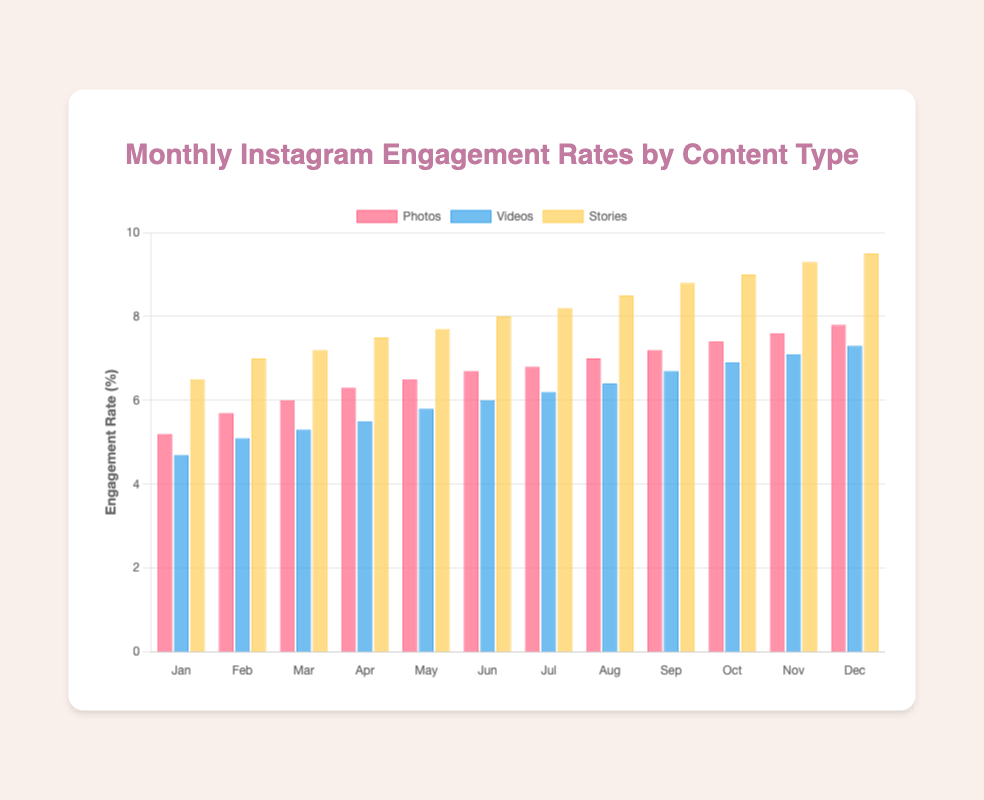What month had the highest engagement rate for stories? Stories had the highest engagement rate in December. By looking at the height of the yellow bars representing stories, December's bar is the tallest.
Answer: December Which content type had the lowest engagement rate in January? By comparing the heights of the bars for January, the blue bar (Videos) is the shortest, indicating it's the content type with the lowest engagement rate for that month.
Answer: Videos Which month saw the greatest increase in engagement rate for photos compared to the previous month? Calculate the month-over-month change for photos: 
- Jan to Feb: 5.7 - 5.2 = 0.5
- Feb to Mar: 6.0 - 5.7 = 0.3
- Mar to Apr: 6.3 - 6.0 = 0.3
- Apr to May: 6.5 - 6.3 = 0.2
- May to Jun: 6.7 - 6.5 = 0.2
- Jun to Jul: 6.8 - 6.7 = 0.1
- Jul to Aug: 7.0 - 6.8 = 0.2
- Aug to Sep: 7.2 - 7.0 = 0.2
- Sep to Oct: 7.4 - 7.2 = 0.2
- Oct to Nov: 7.6 - 7.4 = 0.2
- Nov to Dec: 7.8 - 7.6 = 0.2
The greatest increase, 0.5, is from January to February.
Answer: February What’s the average engagement rate for videos in the first quarter (January to March)? The engagement rates for videos in January, February, and March are 4.7, 5.1, and 5.3, respectively. Sum them up (4.7 + 5.1 + 5.3) = 15.1, then average 15.1 / 3 = 5.03.
Answer: 5.03 Was there any month where videos had a higher engagement rate than both photos and stories? By comparing each month's engagement rates, there is no month where the blue bar (Videos) is taller than both the red bar (Photos) and yellow bar (Stories).
Answer: No What's the total engagement rate for all content types in December? Sum the engagement rates for photos, videos, and stories in December (7.8 + 7.3 + 9.5) = 24.6.
Answer: 24.6 Which content type shows a steady increase in engagement rate every month? By observing the bars, all three content types (photos, videos, and stories) show a steady increase in engagement rates each month as each successive bar is always taller than the prior month's bar.
Answer: Photos, Videos, and Stories What’s the percentage increase in engagement rate for stories from January to December? Calculate the increase: 9.5 - 6.5 = 3. Then, determine the percentage increase: (3 / 6.5) * 100 = 46.15%.
Answer: 46.15% 